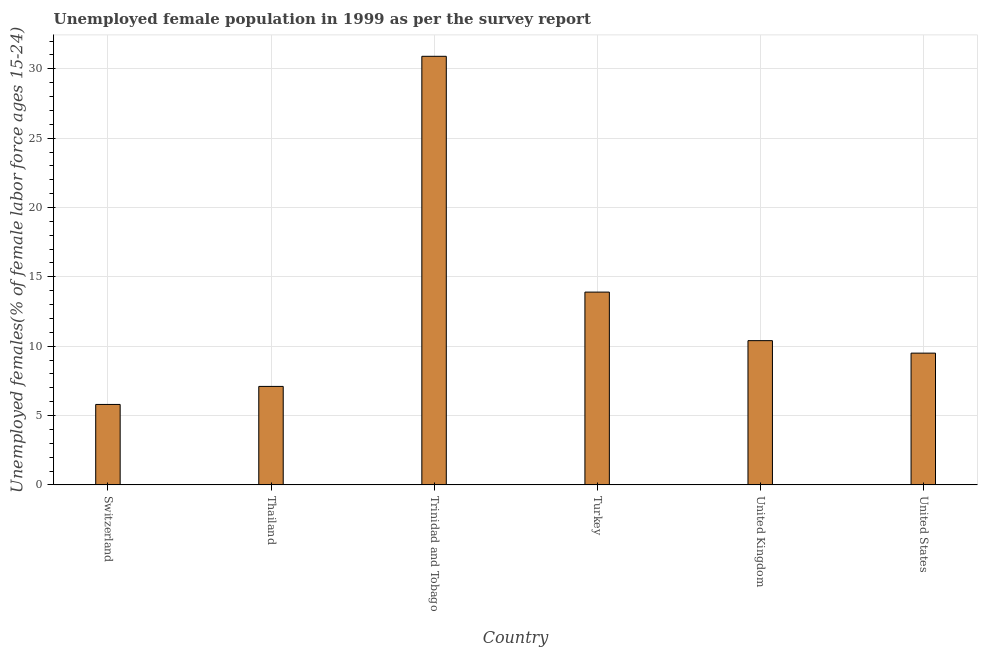What is the title of the graph?
Your answer should be very brief. Unemployed female population in 1999 as per the survey report. What is the label or title of the X-axis?
Make the answer very short. Country. What is the label or title of the Y-axis?
Give a very brief answer. Unemployed females(% of female labor force ages 15-24). What is the unemployed female youth in United States?
Offer a very short reply. 9.5. Across all countries, what is the maximum unemployed female youth?
Your answer should be very brief. 30.9. Across all countries, what is the minimum unemployed female youth?
Your answer should be compact. 5.8. In which country was the unemployed female youth maximum?
Provide a short and direct response. Trinidad and Tobago. In which country was the unemployed female youth minimum?
Give a very brief answer. Switzerland. What is the sum of the unemployed female youth?
Your answer should be compact. 77.6. What is the average unemployed female youth per country?
Your response must be concise. 12.93. What is the median unemployed female youth?
Offer a very short reply. 9.95. What is the ratio of the unemployed female youth in Turkey to that in United Kingdom?
Offer a terse response. 1.34. Is the unemployed female youth in Thailand less than that in Turkey?
Your answer should be very brief. Yes. Is the difference between the unemployed female youth in Thailand and Turkey greater than the difference between any two countries?
Give a very brief answer. No. What is the difference between the highest and the second highest unemployed female youth?
Give a very brief answer. 17. Is the sum of the unemployed female youth in Trinidad and Tobago and United States greater than the maximum unemployed female youth across all countries?
Make the answer very short. Yes. What is the difference between the highest and the lowest unemployed female youth?
Give a very brief answer. 25.1. How many countries are there in the graph?
Offer a terse response. 6. What is the Unemployed females(% of female labor force ages 15-24) in Switzerland?
Offer a very short reply. 5.8. What is the Unemployed females(% of female labor force ages 15-24) of Thailand?
Your response must be concise. 7.1. What is the Unemployed females(% of female labor force ages 15-24) of Trinidad and Tobago?
Provide a succinct answer. 30.9. What is the Unemployed females(% of female labor force ages 15-24) of Turkey?
Your answer should be very brief. 13.9. What is the Unemployed females(% of female labor force ages 15-24) in United Kingdom?
Give a very brief answer. 10.4. What is the Unemployed females(% of female labor force ages 15-24) of United States?
Provide a short and direct response. 9.5. What is the difference between the Unemployed females(% of female labor force ages 15-24) in Switzerland and Thailand?
Offer a terse response. -1.3. What is the difference between the Unemployed females(% of female labor force ages 15-24) in Switzerland and Trinidad and Tobago?
Your answer should be very brief. -25.1. What is the difference between the Unemployed females(% of female labor force ages 15-24) in Switzerland and Turkey?
Your answer should be compact. -8.1. What is the difference between the Unemployed females(% of female labor force ages 15-24) in Switzerland and United States?
Offer a very short reply. -3.7. What is the difference between the Unemployed females(% of female labor force ages 15-24) in Thailand and Trinidad and Tobago?
Keep it short and to the point. -23.8. What is the difference between the Unemployed females(% of female labor force ages 15-24) in Thailand and United Kingdom?
Ensure brevity in your answer.  -3.3. What is the difference between the Unemployed females(% of female labor force ages 15-24) in Trinidad and Tobago and United States?
Give a very brief answer. 21.4. What is the ratio of the Unemployed females(% of female labor force ages 15-24) in Switzerland to that in Thailand?
Your response must be concise. 0.82. What is the ratio of the Unemployed females(% of female labor force ages 15-24) in Switzerland to that in Trinidad and Tobago?
Offer a very short reply. 0.19. What is the ratio of the Unemployed females(% of female labor force ages 15-24) in Switzerland to that in Turkey?
Your answer should be very brief. 0.42. What is the ratio of the Unemployed females(% of female labor force ages 15-24) in Switzerland to that in United Kingdom?
Provide a succinct answer. 0.56. What is the ratio of the Unemployed females(% of female labor force ages 15-24) in Switzerland to that in United States?
Offer a very short reply. 0.61. What is the ratio of the Unemployed females(% of female labor force ages 15-24) in Thailand to that in Trinidad and Tobago?
Your answer should be very brief. 0.23. What is the ratio of the Unemployed females(% of female labor force ages 15-24) in Thailand to that in Turkey?
Ensure brevity in your answer.  0.51. What is the ratio of the Unemployed females(% of female labor force ages 15-24) in Thailand to that in United Kingdom?
Make the answer very short. 0.68. What is the ratio of the Unemployed females(% of female labor force ages 15-24) in Thailand to that in United States?
Give a very brief answer. 0.75. What is the ratio of the Unemployed females(% of female labor force ages 15-24) in Trinidad and Tobago to that in Turkey?
Provide a short and direct response. 2.22. What is the ratio of the Unemployed females(% of female labor force ages 15-24) in Trinidad and Tobago to that in United Kingdom?
Make the answer very short. 2.97. What is the ratio of the Unemployed females(% of female labor force ages 15-24) in Trinidad and Tobago to that in United States?
Make the answer very short. 3.25. What is the ratio of the Unemployed females(% of female labor force ages 15-24) in Turkey to that in United Kingdom?
Provide a succinct answer. 1.34. What is the ratio of the Unemployed females(% of female labor force ages 15-24) in Turkey to that in United States?
Make the answer very short. 1.46. What is the ratio of the Unemployed females(% of female labor force ages 15-24) in United Kingdom to that in United States?
Keep it short and to the point. 1.09. 